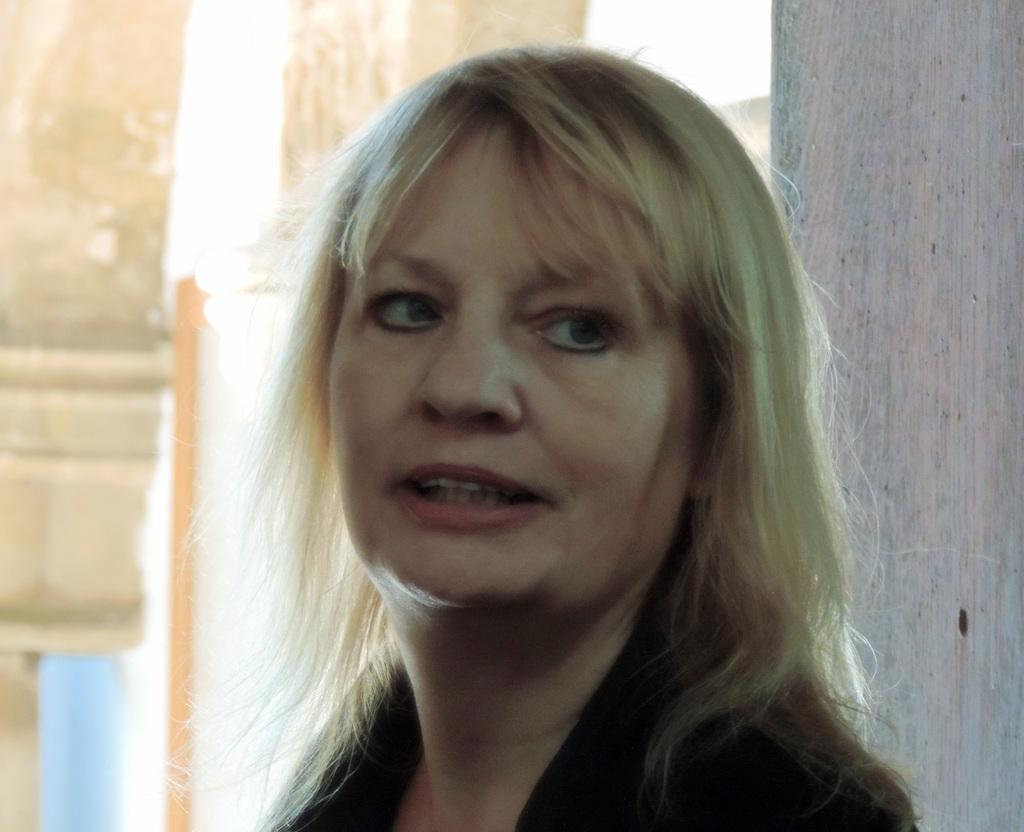Who is the main subject in the image? There is a lady in the image. What is the lady wearing? The lady is wearing a black dress. Can you describe the background of the image? The background of the image is blurred. What type of education does the lady have in the image? There is no information about the lady's education in the image. What color is the lady's underwear in the image? There is no information about the lady's underwear in the image. 